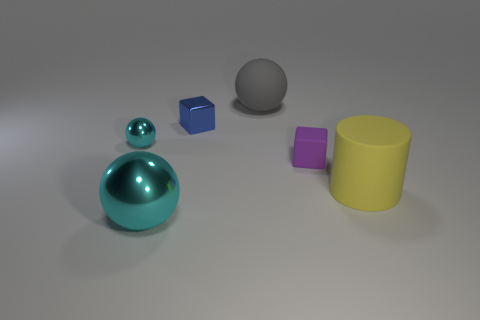What size is the other shiny ball that is the same color as the tiny metal ball?
Offer a terse response. Large. Are there an equal number of things right of the yellow rubber cylinder and large gray spheres that are on the left side of the small cyan metal sphere?
Ensure brevity in your answer.  Yes. How many things are either large cylinders or green cylinders?
Give a very brief answer. 1. There is another block that is the same size as the rubber block; what is its color?
Keep it short and to the point. Blue. How many things are either balls in front of the gray matte thing or large objects in front of the gray rubber thing?
Your response must be concise. 3. Is the number of yellow cylinders to the left of the large gray ball the same as the number of metal balls?
Give a very brief answer. No. Do the block in front of the blue metal block and the block to the left of the gray matte thing have the same size?
Offer a very short reply. Yes. How many other things are the same size as the gray object?
Keep it short and to the point. 2. Are there any large objects to the left of the cyan shiny sphere behind the big ball that is in front of the yellow cylinder?
Your answer should be very brief. No. Are there any other things that have the same color as the large shiny ball?
Keep it short and to the point. Yes. 